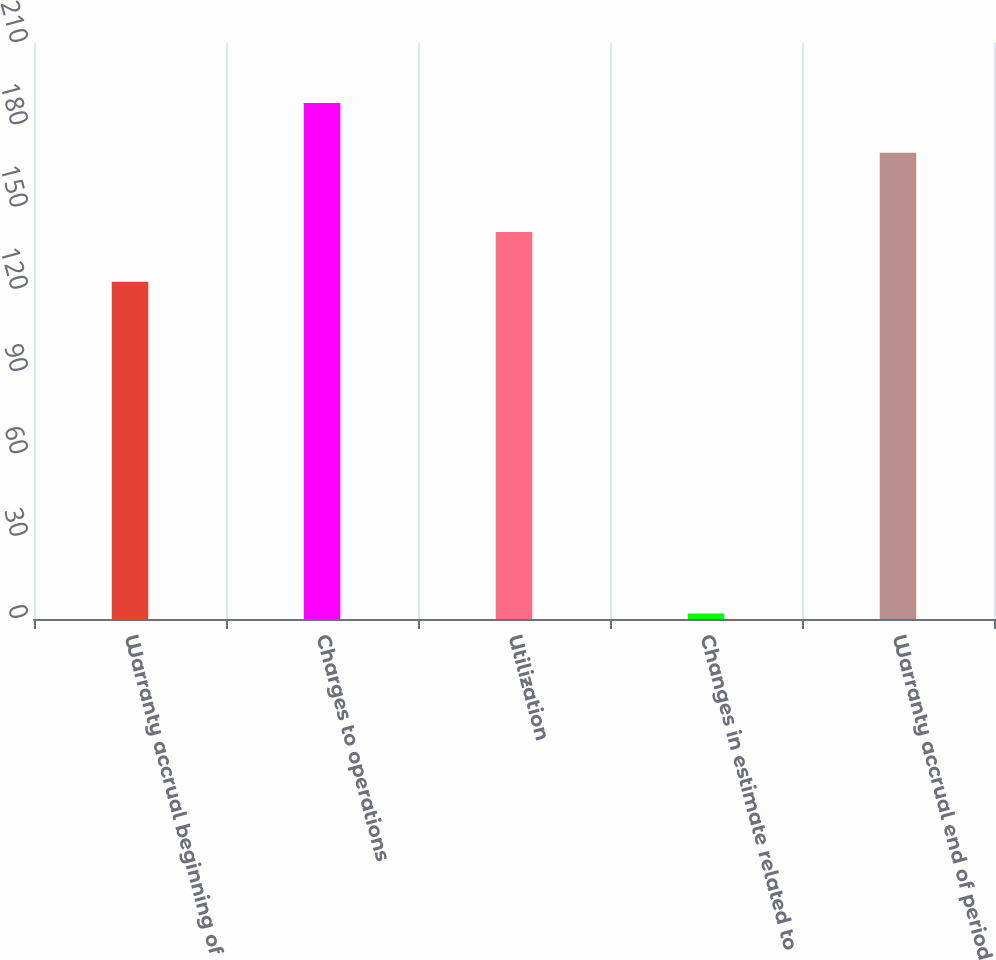Convert chart. <chart><loc_0><loc_0><loc_500><loc_500><bar_chart><fcel>Warranty accrual beginning of<fcel>Charges to operations<fcel>Utilization<fcel>Changes in estimate related to<fcel>Warranty accrual end of period<nl><fcel>123<fcel>188.1<fcel>141.1<fcel>2<fcel>170<nl></chart> 